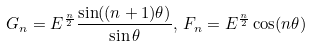<formula> <loc_0><loc_0><loc_500><loc_500>G _ { n } = E ^ { \frac { n } { 2 } } \frac { \sin ( ( n + 1 ) \theta ) } { \sin \theta } , \, F _ { n } = E ^ { \frac { n } { 2 } } \cos ( n \theta )</formula> 